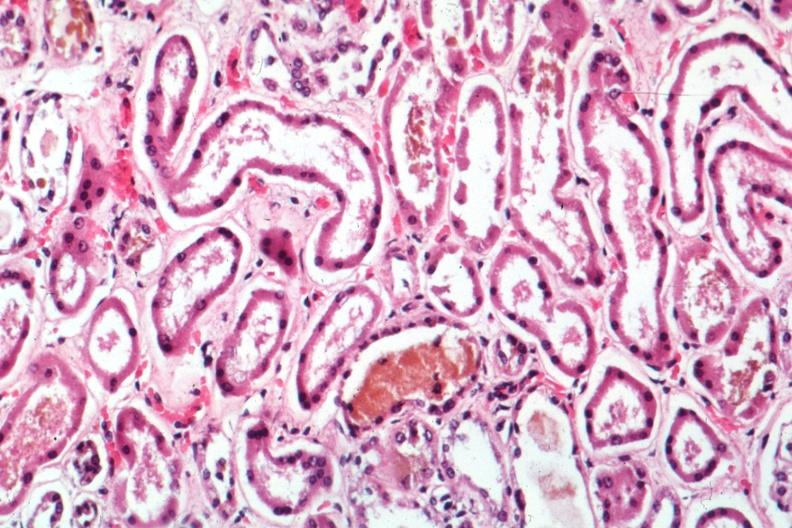does this image show mad dilated tubules with missing and pyknotic nuclei and bile in one quite good?
Answer the question using a single word or phrase. Yes 